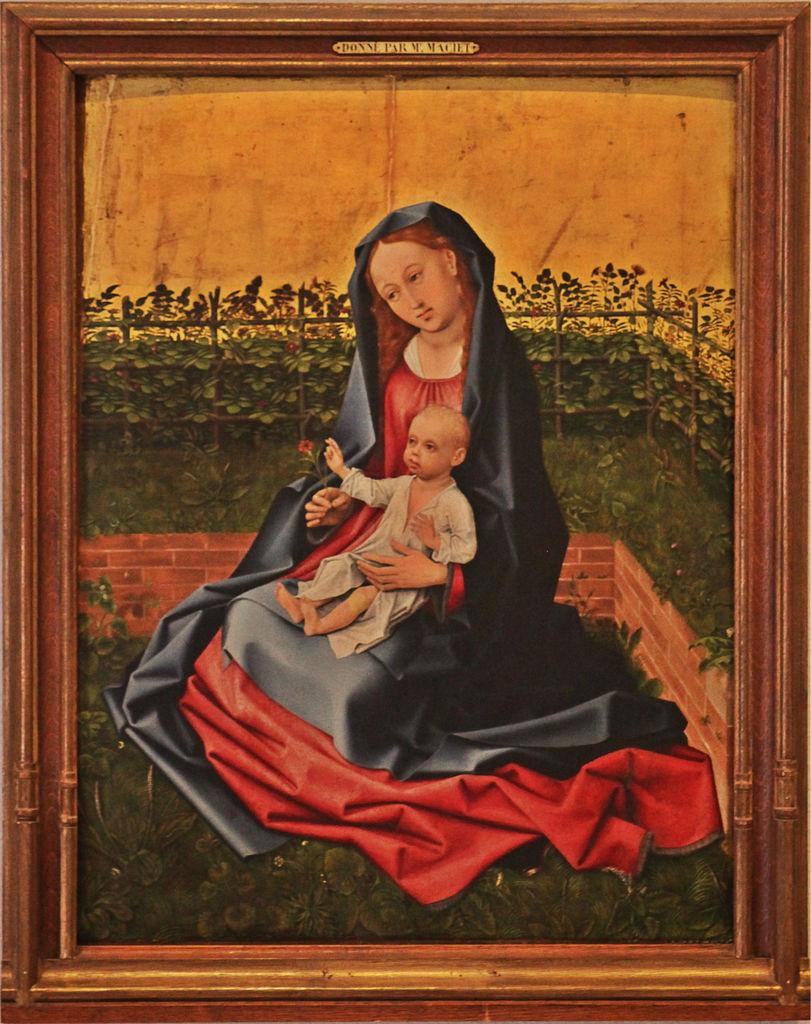Do you see any text?
Keep it short and to the point. Yes. 